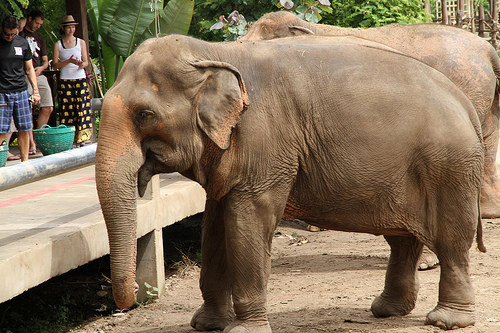Can you describe the environment where the elephant is standing? The environment where the elephant is standing appears to be a zoo or an animal sanctuary. There is a concrete path with a metal railing on one side and a dirt ground on the other. The area is surrounded by green foliage, indicating a lush and natural habitat for the animals. Are there any other animals visible in the image? There are no other animals visibly clear in the image aside from the elephant in the front. Who can be seen in the background of the image? In the background of the image, there are people, including a man on the left side and a girl towards the center. The man is wearing a black t-shirt and plaid shorts, while the girl appears to be standing close to the elephant, wearing a skirt. What is the overall feeling that the image conveys? The overall feeling of the image seems to be calm and peaceful. The elephant looks relaxed, and the people around it are observing the animal with interest. The greenery in the background adds to the serene ambiance. 